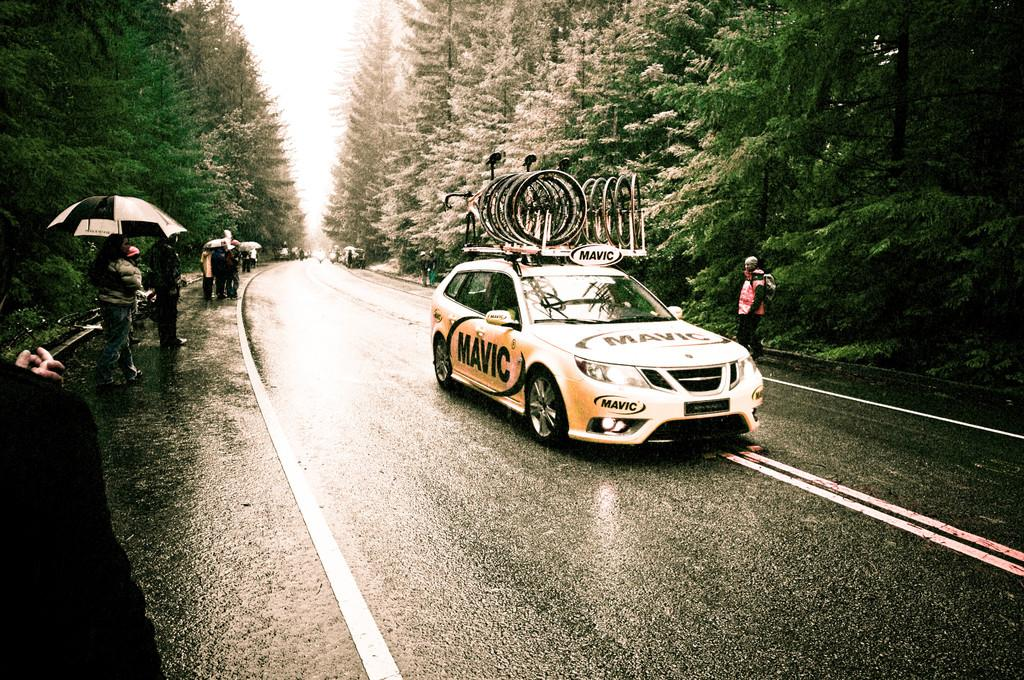What can be inferred about the image based on the fact that it has been edited? The image has been altered or modified in some way. What type of natural scenery is visible at the top of the image? There are trees at the top of the image. What is the main mode of transportation in the image? There is a car in the middle of the image. What might the persons in the image be using to protect themselves from the weather? The persons holding umbrellas in the image might be using them to protect themselves from rain or sun. What type of fiction is being read by the birds in the image? There are no birds present in the image, so it is not possible to determine if they are reading any fiction. 